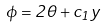Convert formula to latex. <formula><loc_0><loc_0><loc_500><loc_500>\phi = 2 \theta + c _ { 1 } y</formula> 